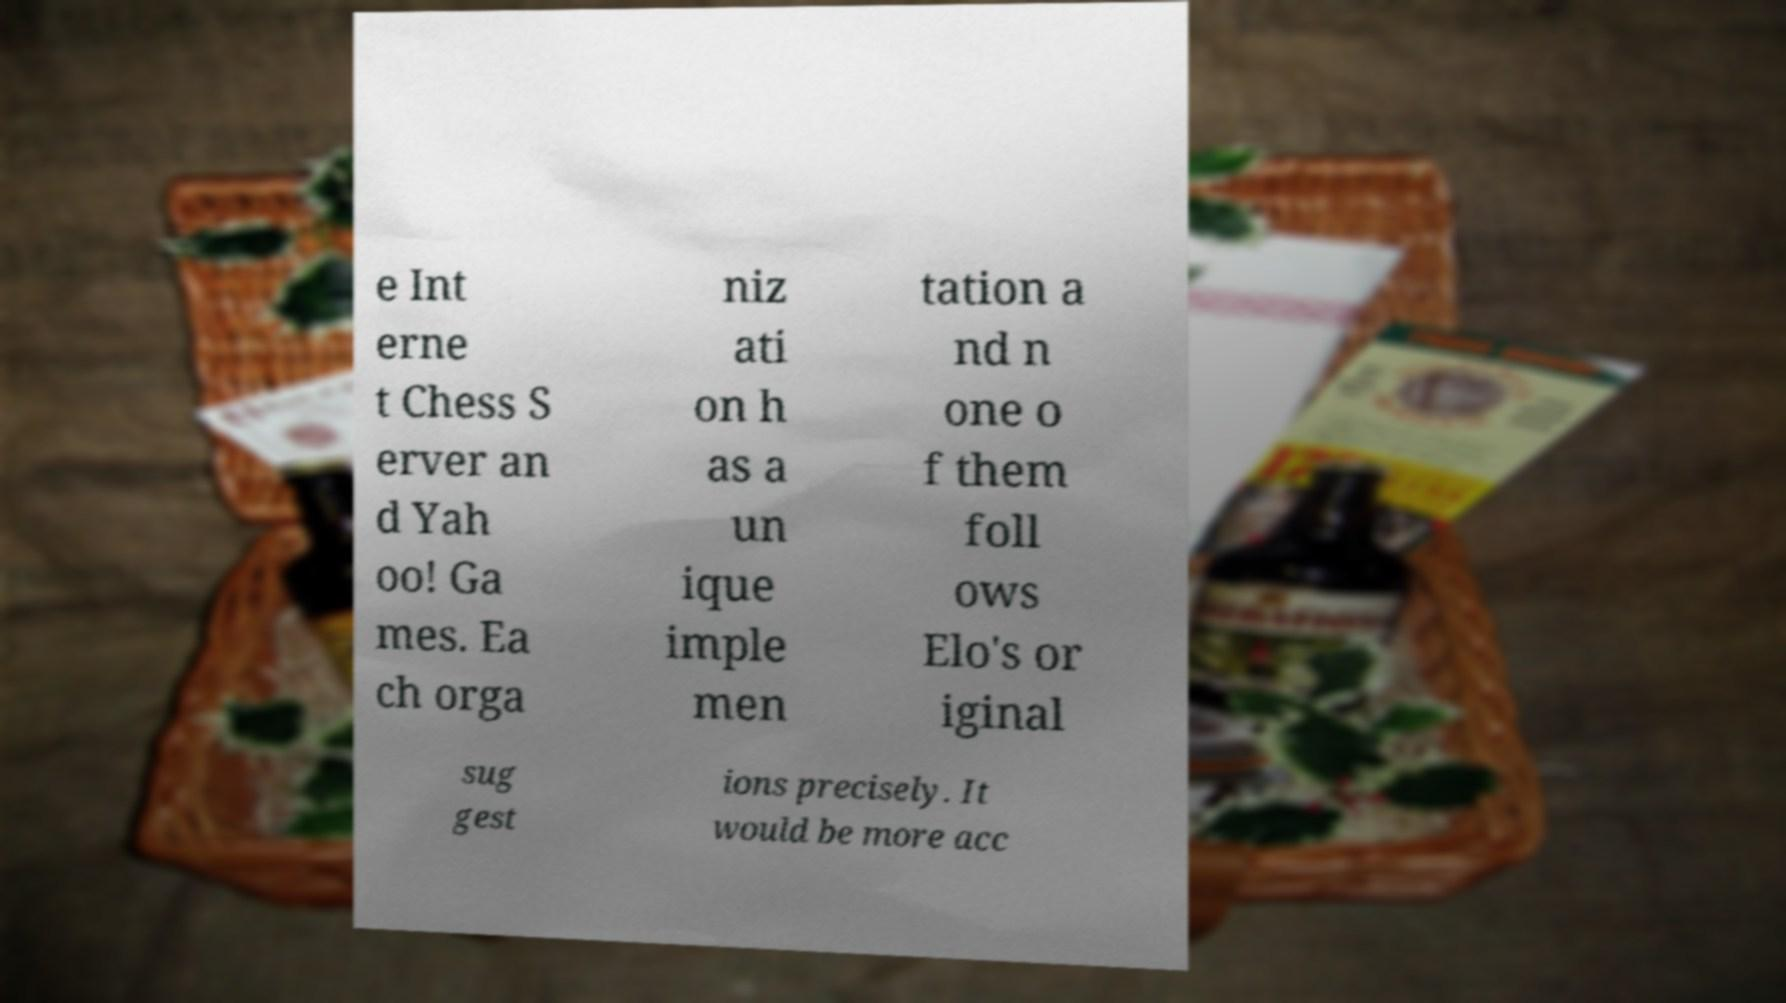Please read and relay the text visible in this image. What does it say? e Int erne t Chess S erver an d Yah oo! Ga mes. Ea ch orga niz ati on h as a un ique imple men tation a nd n one o f them foll ows Elo's or iginal sug gest ions precisely. It would be more acc 